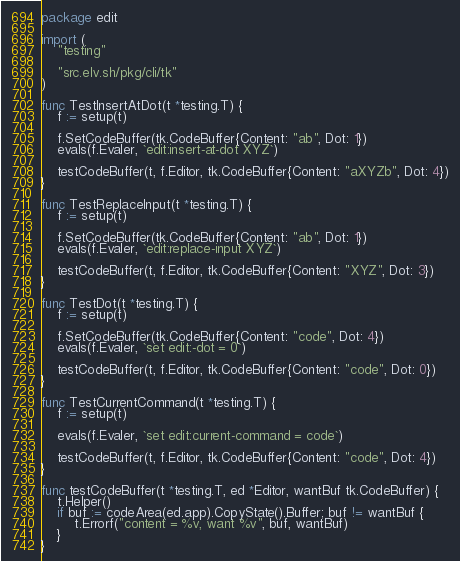Convert code to text. <code><loc_0><loc_0><loc_500><loc_500><_Go_>package edit

import (
	"testing"

	"src.elv.sh/pkg/cli/tk"
)

func TestInsertAtDot(t *testing.T) {
	f := setup(t)

	f.SetCodeBuffer(tk.CodeBuffer{Content: "ab", Dot: 1})
	evals(f.Evaler, `edit:insert-at-dot XYZ`)

	testCodeBuffer(t, f.Editor, tk.CodeBuffer{Content: "aXYZb", Dot: 4})
}

func TestReplaceInput(t *testing.T) {
	f := setup(t)

	f.SetCodeBuffer(tk.CodeBuffer{Content: "ab", Dot: 1})
	evals(f.Evaler, `edit:replace-input XYZ`)

	testCodeBuffer(t, f.Editor, tk.CodeBuffer{Content: "XYZ", Dot: 3})
}

func TestDot(t *testing.T) {
	f := setup(t)

	f.SetCodeBuffer(tk.CodeBuffer{Content: "code", Dot: 4})
	evals(f.Evaler, `set edit:-dot = 0`)

	testCodeBuffer(t, f.Editor, tk.CodeBuffer{Content: "code", Dot: 0})
}

func TestCurrentCommand(t *testing.T) {
	f := setup(t)

	evals(f.Evaler, `set edit:current-command = code`)

	testCodeBuffer(t, f.Editor, tk.CodeBuffer{Content: "code", Dot: 4})
}

func testCodeBuffer(t *testing.T, ed *Editor, wantBuf tk.CodeBuffer) {
	t.Helper()
	if buf := codeArea(ed.app).CopyState().Buffer; buf != wantBuf {
		t.Errorf("content = %v, want %v", buf, wantBuf)
	}
}
</code> 